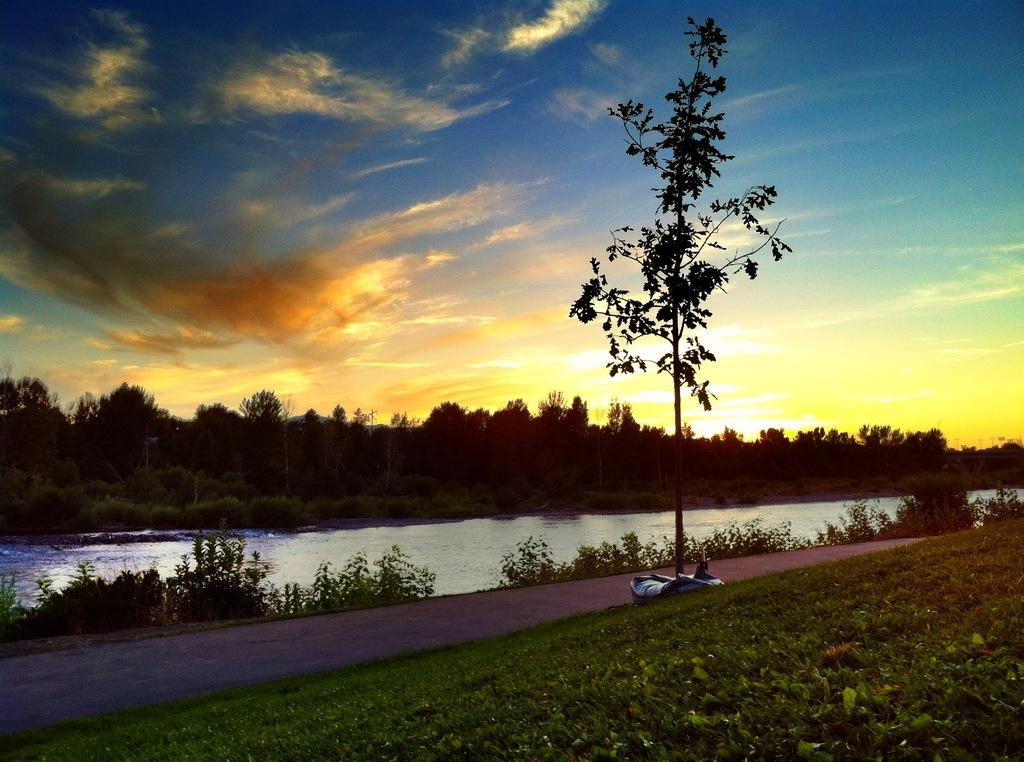What is located on the path in the image? There is an object on the path in the image. What type of vegetation is on the right side of the path? There is grass on the right side of the path. What natural feature is visible behind the path? There is a river behind the path. What else can be seen behind the path? Trees and plants are visible behind the path. What is visible in the background of the image? The sky is visible in the background of the image. What type of popcorn is being served at the war in the image? There is no war or popcorn present in the image. Can you tell me how many mothers are visible in the image? There are no mothers present in the image. 